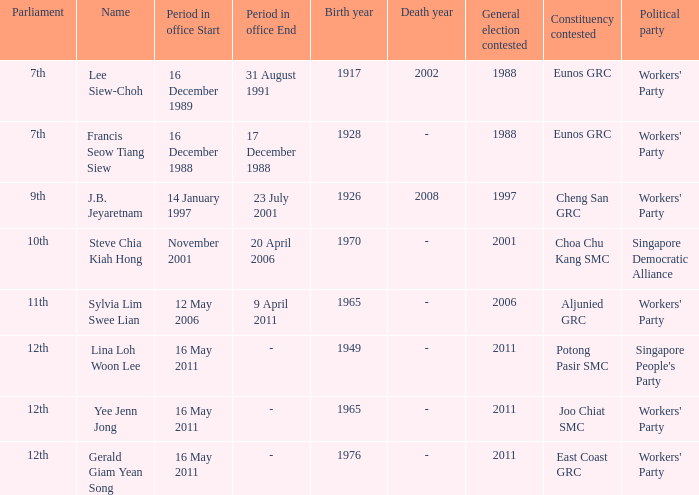What number parliament held it's election in 1997? 9th. Could you help me parse every detail presented in this table? {'header': ['Parliament', 'Name', 'Period in office Start', 'Period in office End', 'Birth year', 'Death year', 'General election contested', 'Constituency contested', 'Political party'], 'rows': [['7th', 'Lee Siew-Choh', '16 December 1989', '31 August 1991', '1917', '2002', '1988', 'Eunos GRC', "Workers' Party"], ['7th', 'Francis Seow Tiang Siew', '16 December 1988', '17 December 1988', '1928', '-', '1988', 'Eunos GRC', "Workers' Party"], ['9th', 'J.B. Jeyaretnam', '14 January 1997', '23 July 2001', '1926', '2008', '1997', 'Cheng San GRC', "Workers' Party"], ['10th', 'Steve Chia Kiah Hong', 'November 2001', '20 April 2006', '1970', '-', '2001', 'Choa Chu Kang SMC', 'Singapore Democratic Alliance'], ['11th', 'Sylvia Lim Swee Lian', '12 May 2006', '9 April 2011', '1965', '-', '2006', 'Aljunied GRC', "Workers' Party"], ['12th', 'Lina Loh Woon Lee', '16 May 2011', '-', '1949', '-', '2011', 'Potong Pasir SMC', "Singapore People's Party"], ['12th', 'Yee Jenn Jong', '16 May 2011', '-', '1965', '-', '2011', 'Joo Chiat SMC', "Workers' Party"], ['12th', 'Gerald Giam Yean Song', '16 May 2011', '-', '1976', '-', '2011', 'East Coast GRC', "Workers' Party"]]} 